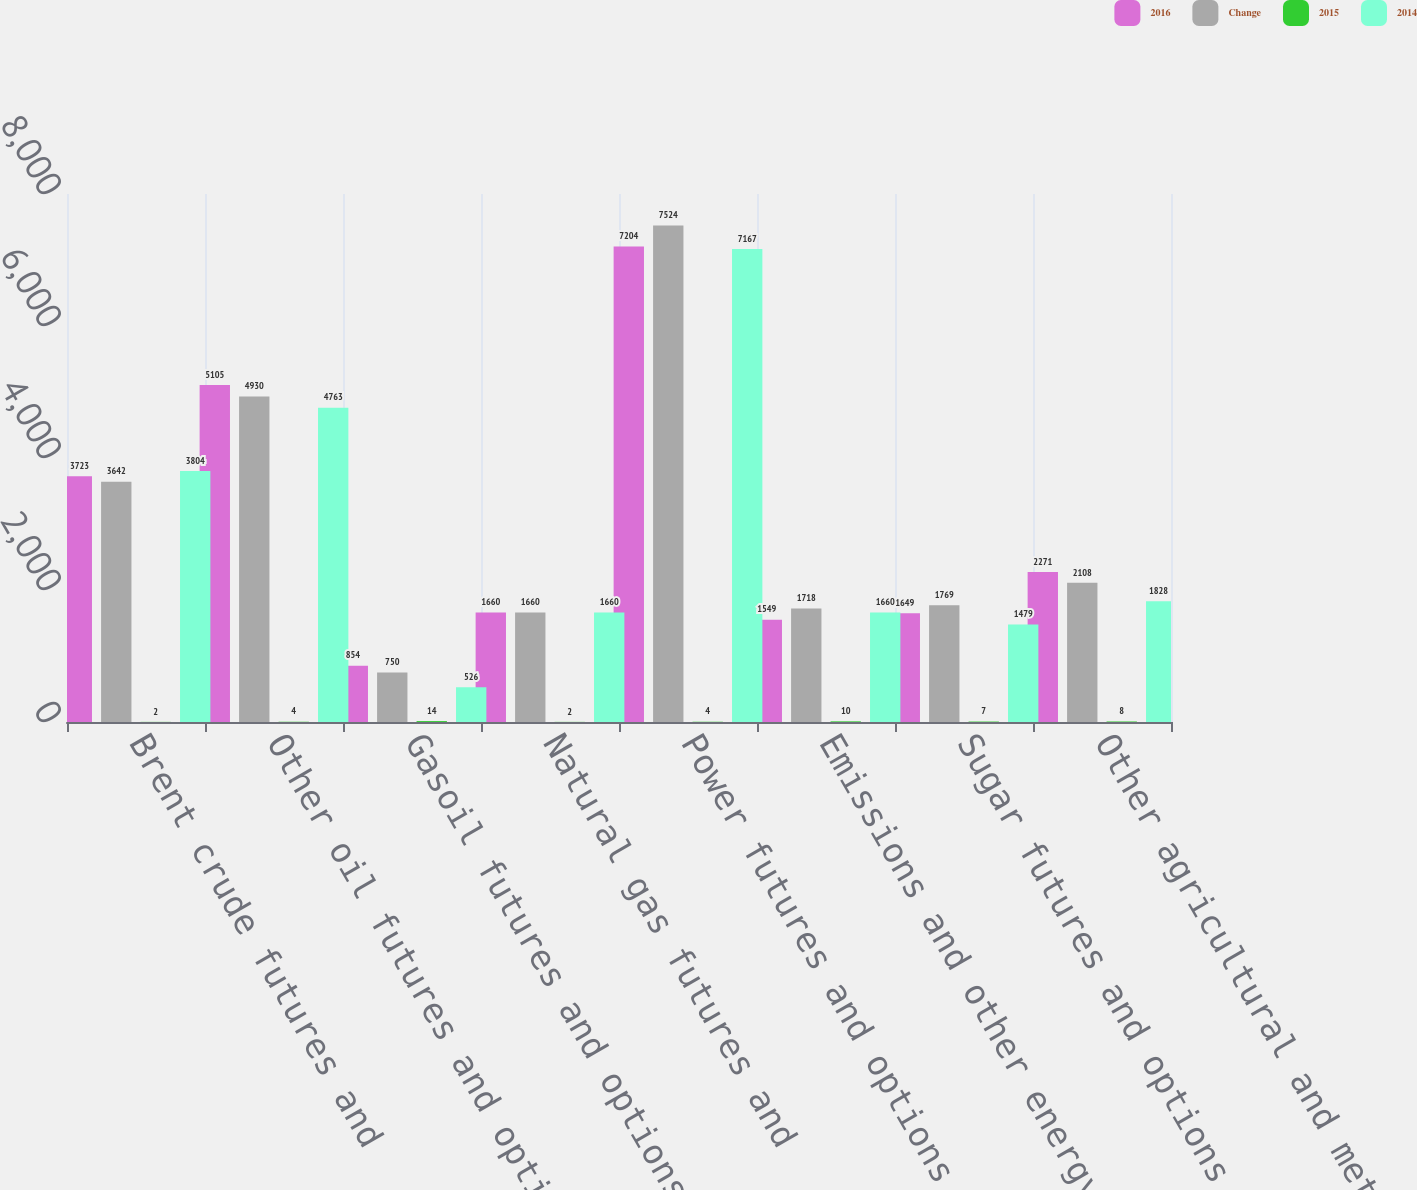<chart> <loc_0><loc_0><loc_500><loc_500><stacked_bar_chart><ecel><fcel>Brent crude futures and<fcel>Other oil futures and options<fcel>Gasoil futures and options<fcel>Natural gas futures and<fcel>Power futures and options<fcel>Emissions and other energy<fcel>Sugar futures and options<fcel>Other agricultural and metals<nl><fcel>2016<fcel>3723<fcel>5105<fcel>854<fcel>1660<fcel>7204<fcel>1549<fcel>1649<fcel>2271<nl><fcel>Change<fcel>3642<fcel>4930<fcel>750<fcel>1660<fcel>7524<fcel>1718<fcel>1769<fcel>2108<nl><fcel>2015<fcel>2<fcel>4<fcel>14<fcel>2<fcel>4<fcel>10<fcel>7<fcel>8<nl><fcel>2014<fcel>3804<fcel>4763<fcel>526<fcel>1660<fcel>7167<fcel>1660<fcel>1479<fcel>1828<nl></chart> 